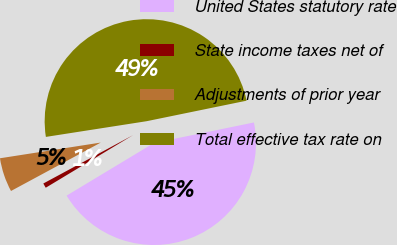Convert chart. <chart><loc_0><loc_0><loc_500><loc_500><pie_chart><fcel>United States statutory rate<fcel>State income taxes net of<fcel>Adjustments of prior year<fcel>Total effective tax rate on<nl><fcel>44.59%<fcel>0.76%<fcel>5.41%<fcel>49.24%<nl></chart> 